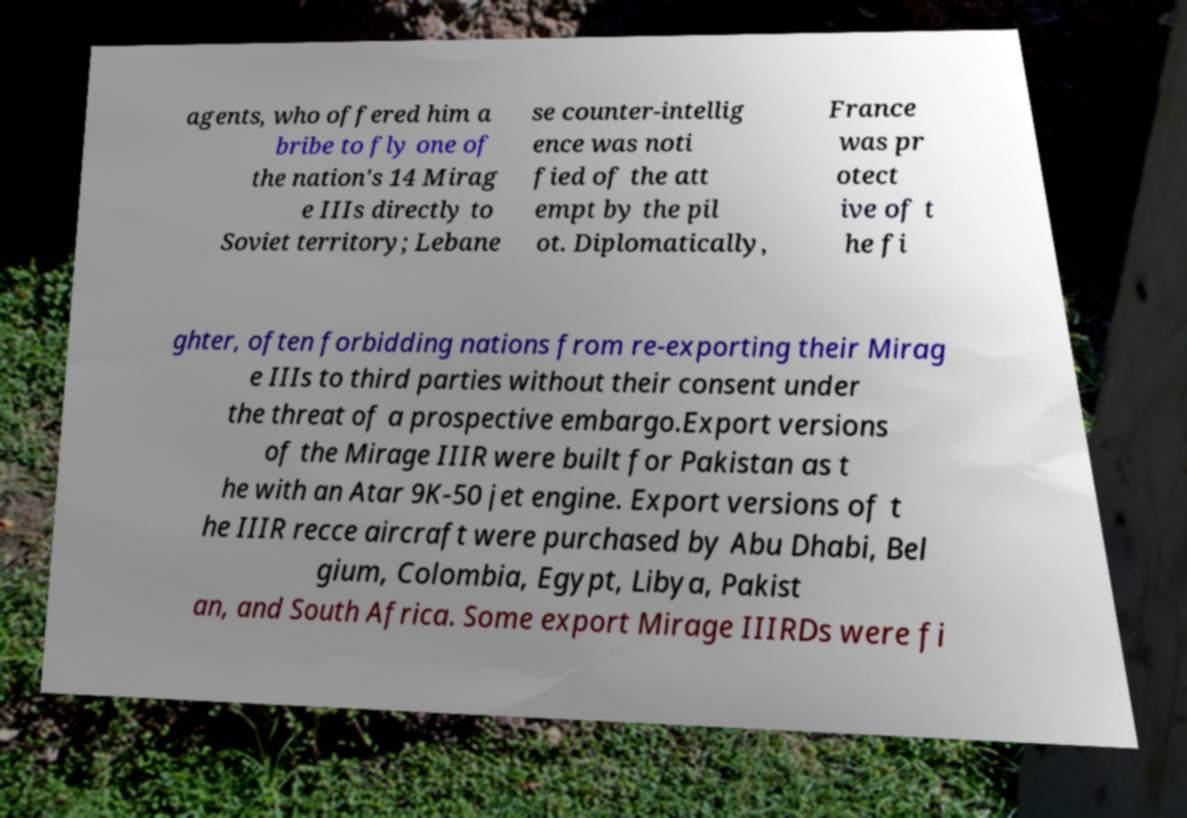Can you accurately transcribe the text from the provided image for me? agents, who offered him a bribe to fly one of the nation's 14 Mirag e IIIs directly to Soviet territory; Lebane se counter-intellig ence was noti fied of the att empt by the pil ot. Diplomatically, France was pr otect ive of t he fi ghter, often forbidding nations from re-exporting their Mirag e IIIs to third parties without their consent under the threat of a prospective embargo.Export versions of the Mirage IIIR were built for Pakistan as t he with an Atar 9K-50 jet engine. Export versions of t he IIIR recce aircraft were purchased by Abu Dhabi, Bel gium, Colombia, Egypt, Libya, Pakist an, and South Africa. Some export Mirage IIIRDs were fi 